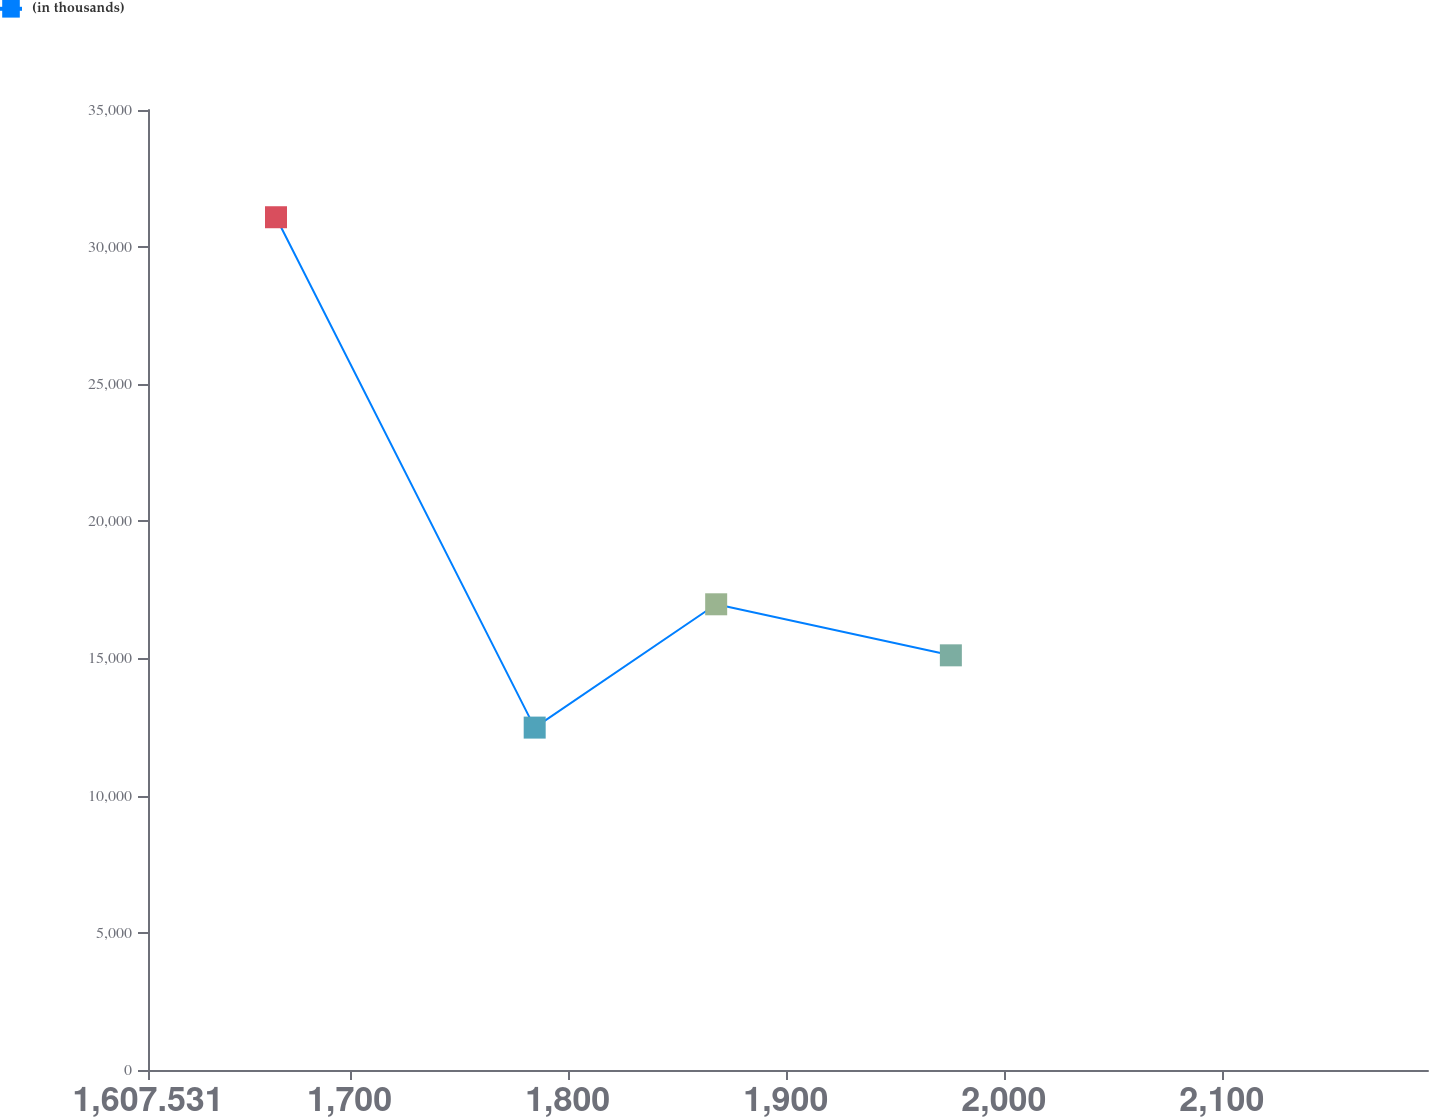Convert chart. <chart><loc_0><loc_0><loc_500><loc_500><line_chart><ecel><fcel>(in thousands)<nl><fcel>1666.23<fcel>31090.5<nl><fcel>1784.86<fcel>12483.2<nl><fcel>1868.09<fcel>16979<nl><fcel>1975.71<fcel>15118.2<nl><fcel>2253.22<fcel>21244.3<nl></chart> 